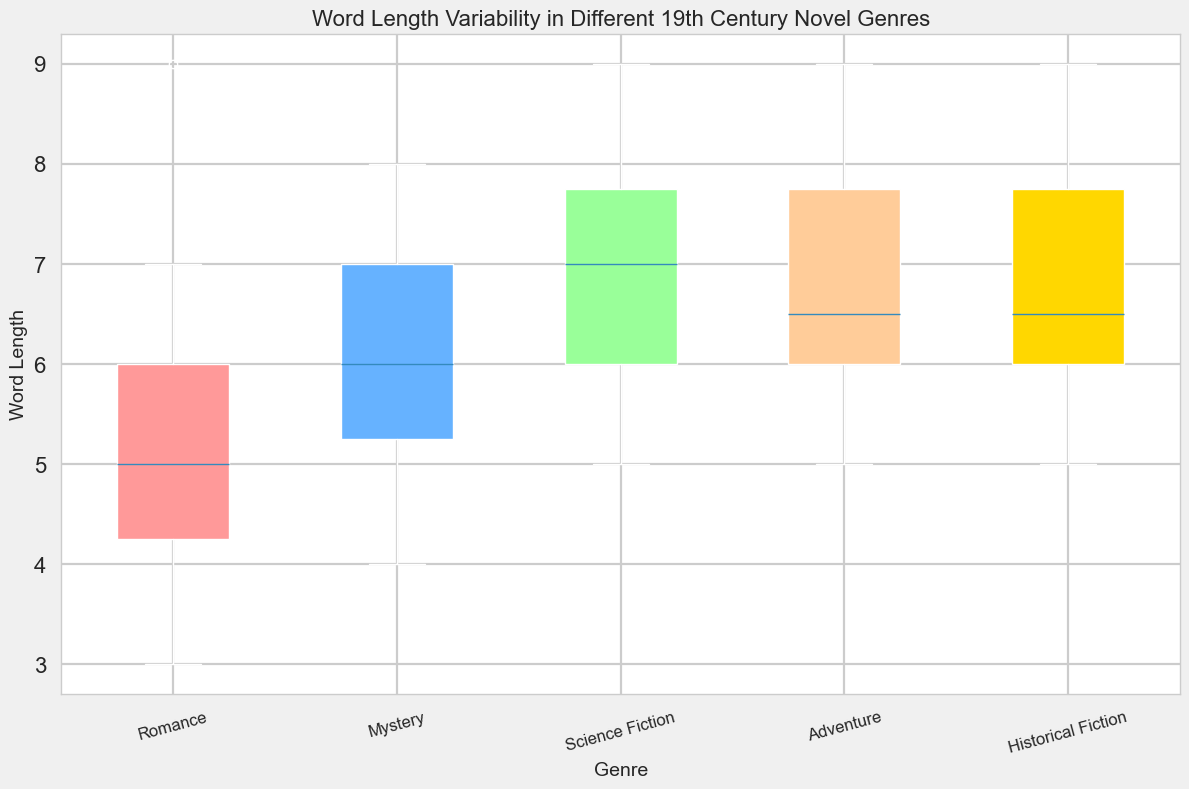What is the median word length in the Romance genre? Look at the box plot for the Romance genre and identify the line that divides the box into two; this line represents the median value.
Answer: 5 Which genre has the largest range of word lengths? The range of word lengths is represented by the distance between the bottom (minimum) and top (maximum) whiskers in each box plot. Identify the genre with the largest distance between these two points.
Answer: Romance Is the median word length higher in Science Fiction or Mystery? Compare the median lines within the boxes of Science Fiction and Mystery. The higher median line indicates the higher word length.
Answer: Science Fiction Which genre has the smallest interquartile range (IQR) for word length? The IQR is the difference between the upper quartile (top of the box) and lower quartile (bottom of the box). Identify the genre whose box height is the smallest.
Answer: Romance Are there any outliers in the word length data for Adventure? Outliers are typically represented by points outside the whiskers of the box plot. Check the box plot for Adventure to see if any points lie beyond the whiskers.
Answer: No What can be inferred about the consistency of word lengths in Historical Fiction compared to Romance? Compare the heights of the boxes and lengths of the whiskers for both genres. A shorter box and whiskers indicate more consistent word lengths.
Answer: Historical Fiction has more consistent word lengths How does the median word length in Adventure compare to that in Historical Fiction? Look at the median lines in the box plots for both Adventure and Historical Fiction. Compare their positions to determine which is higher.
Answer: Equal Which genre has the highest upper quartile word length? The upper quartile is represented by the top line of the box in each box plot. Identify the genre with the highest top line in the box.
Answer: Science Fiction 